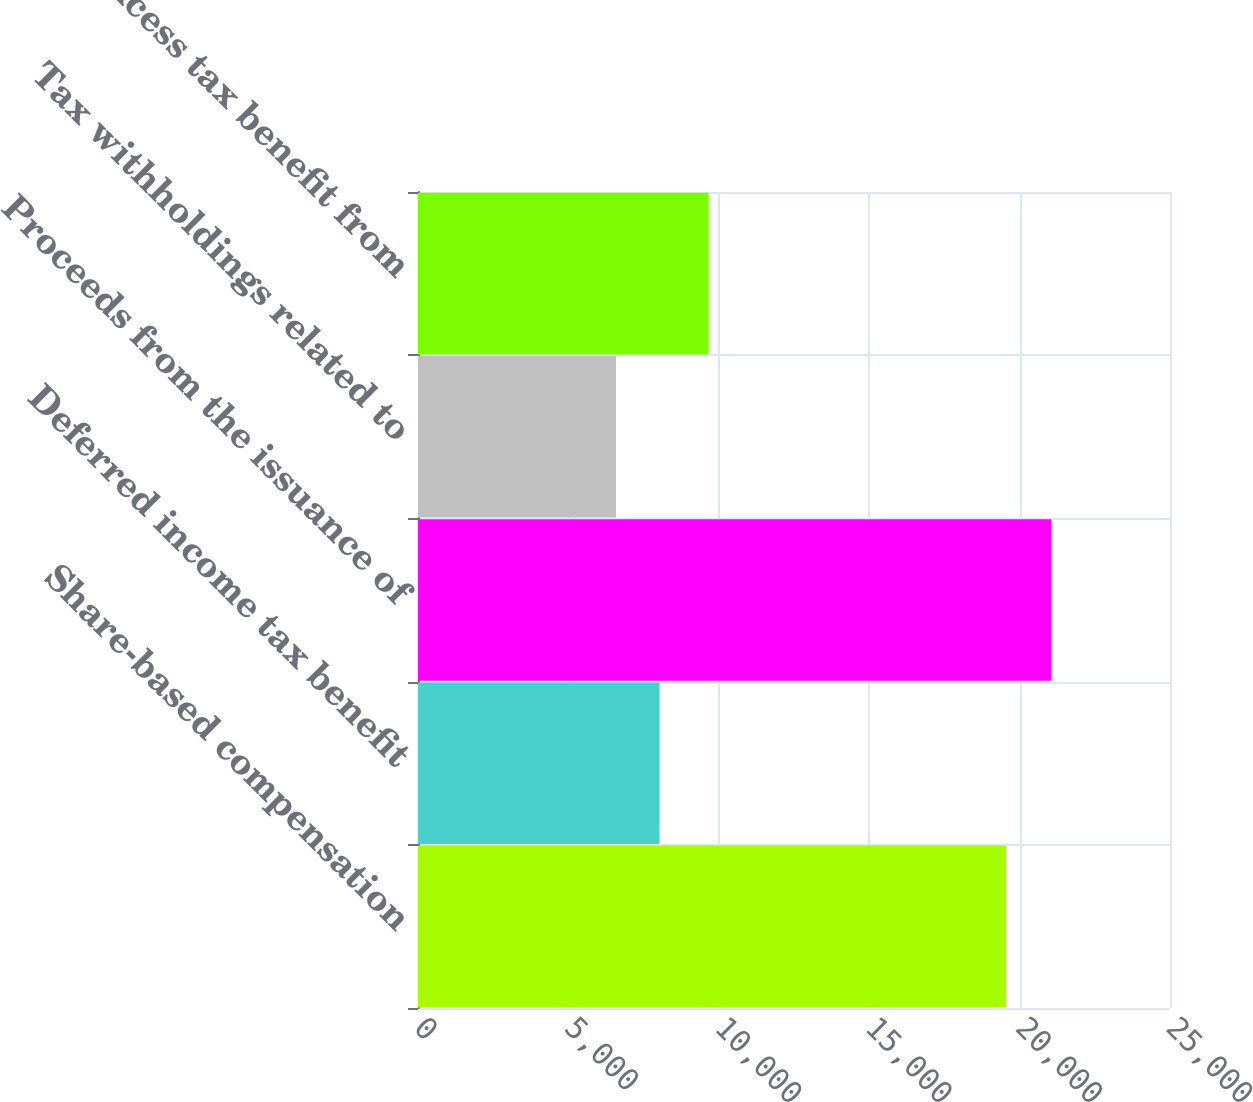Convert chart. <chart><loc_0><loc_0><loc_500><loc_500><bar_chart><fcel>Share-based compensation<fcel>Deferred income tax benefit<fcel>Proceeds from the issuance of<fcel>Tax withholdings related to<fcel>Excess tax benefit from<nl><fcel>19553<fcel>8029.4<fcel>21056<fcel>6582<fcel>9663<nl></chart> 